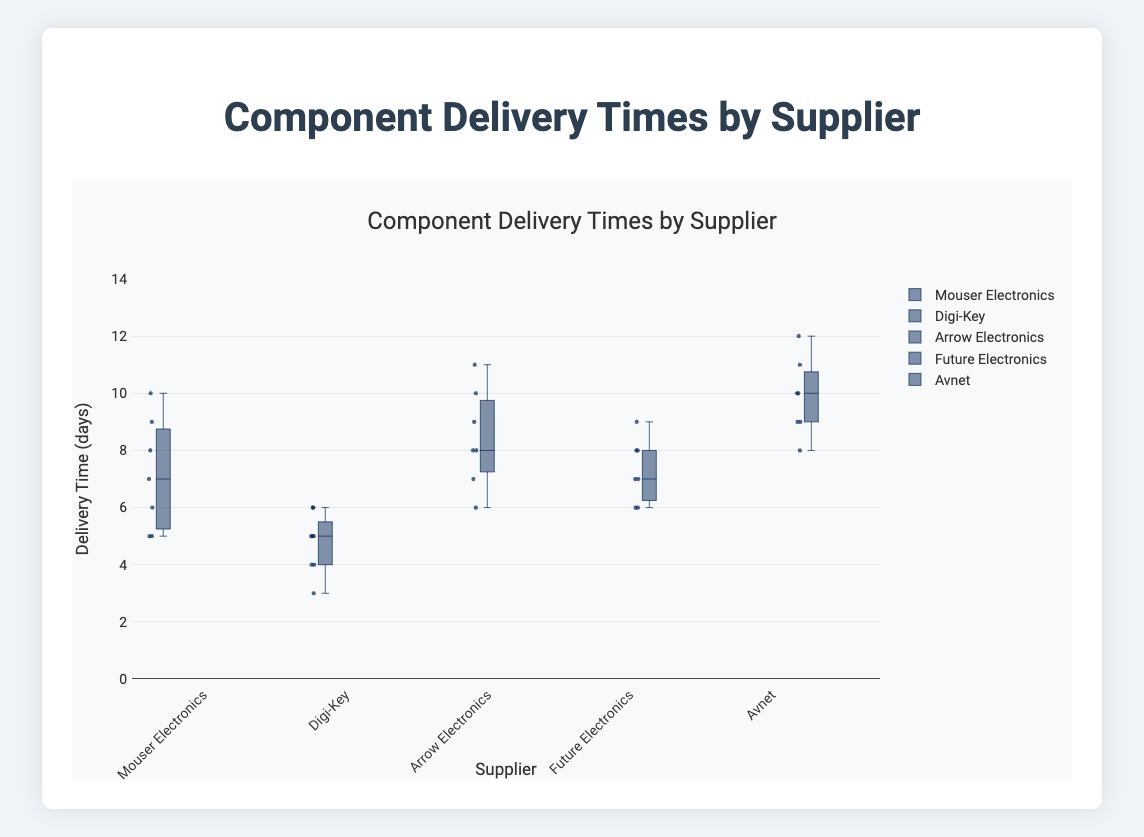What is the title of the figure? The title of the figure is usually located at the top center and represents the main theme of the plot. In this case, it states the overall topic being visualized.
Answer: Component Delivery Times by Supplier What is the unit of measurement for the y-axis? The y-axis label clearly indicates the unit of measurement for delivery times. It allows you to understand in what units the data points are expressed.
Answer: days Which supplier has the shortest median delivery time? To find this, look at the middle line (median) within each box plot. The shortest median line indicates the supplier with the shortest median delivery time.
Answer: Digi-Key Which supplier has the widest range of delivery times? The range of delivery times can be determined by looking at the length of the box and the whiskers for each supplier. The widest range will have the longest whiskers and box combined.
Answer: Avnet What is the interquartile range (IQR) for Arrow Electronics? To calculate the IQR, find the difference between the upper (Q3) and lower (Q1) quartiles in the box plot for Arrow Electronics. The lengths of the box represent this range.
Answer: IQR = Q3 - Q1 = 9 - 7 = 2 Between Mouser Electronics and Future Electronics, which supplier shows more variability in delivery times? Variability is indicated by the spread of the data. Look at the range and the distance of the whiskers from the median for both suppliers. The one with the larger spread shows more variability.
Answer: Mouser Electronics Which supplier has the highest upper whisker value? The upper whisker represents the highest delivery time excluding outliers. Look for the longest top whisker across all box plots to identify the supplier.
Answer: Avnet Between Digi-Key and Arrow Electronics, which supplier has the lower median delivery time? Compare the median lines (central lines in the boxes) for both suppliers. The supplier with the lower median line has the lower median delivery time.
Answer: Digi-Key What is the range of delivery times for Future Electronics? The range is determined by the difference between the maximum and minimum values represented by the whiskers. Find these values for Future Electronics and subtract the minimum from the maximum.
Answer: 9 - 6 = 3 Considering both the spread and median values, which supplier has the most consistent delivery times? Consistency can be evaluated by smaller IQR and closer medians to other values. Check the smallest IQR and a tightly packed box with minimal whisker length.
Answer: Digi-Key 